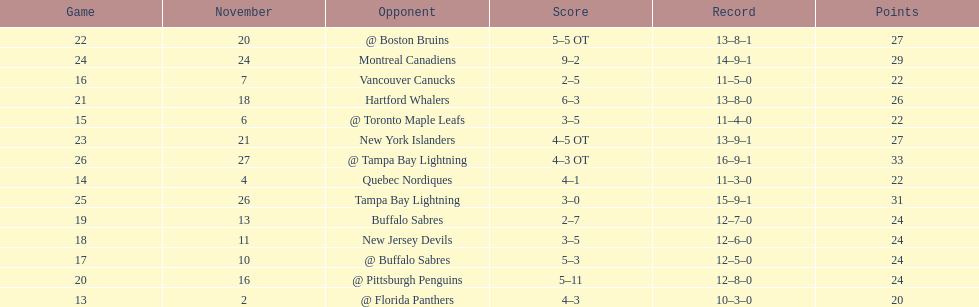Which was the only team in the atlantic division in the 1993-1994 season to acquire less points than the philadelphia flyers? Tampa Bay Lightning. Help me parse the entirety of this table. {'header': ['Game', 'November', 'Opponent', 'Score', 'Record', 'Points'], 'rows': [['22', '20', '@ Boston Bruins', '5–5 OT', '13–8–1', '27'], ['24', '24', 'Montreal Canadiens', '9–2', '14–9–1', '29'], ['16', '7', 'Vancouver Canucks', '2–5', '11–5–0', '22'], ['21', '18', 'Hartford Whalers', '6–3', '13–8–0', '26'], ['15', '6', '@ Toronto Maple Leafs', '3–5', '11–4–0', '22'], ['23', '21', 'New York Islanders', '4–5 OT', '13–9–1', '27'], ['26', '27', '@ Tampa Bay Lightning', '4–3 OT', '16–9–1', '33'], ['14', '4', 'Quebec Nordiques', '4–1', '11–3–0', '22'], ['25', '26', 'Tampa Bay Lightning', '3–0', '15–9–1', '31'], ['19', '13', 'Buffalo Sabres', '2–7', '12–7–0', '24'], ['18', '11', 'New Jersey Devils', '3–5', '12–6–0', '24'], ['17', '10', '@ Buffalo Sabres', '5–3', '12–5–0', '24'], ['20', '16', '@ Pittsburgh Penguins', '5–11', '12–8–0', '24'], ['13', '2', '@ Florida Panthers', '4–3', '10–3–0', '20']]} 